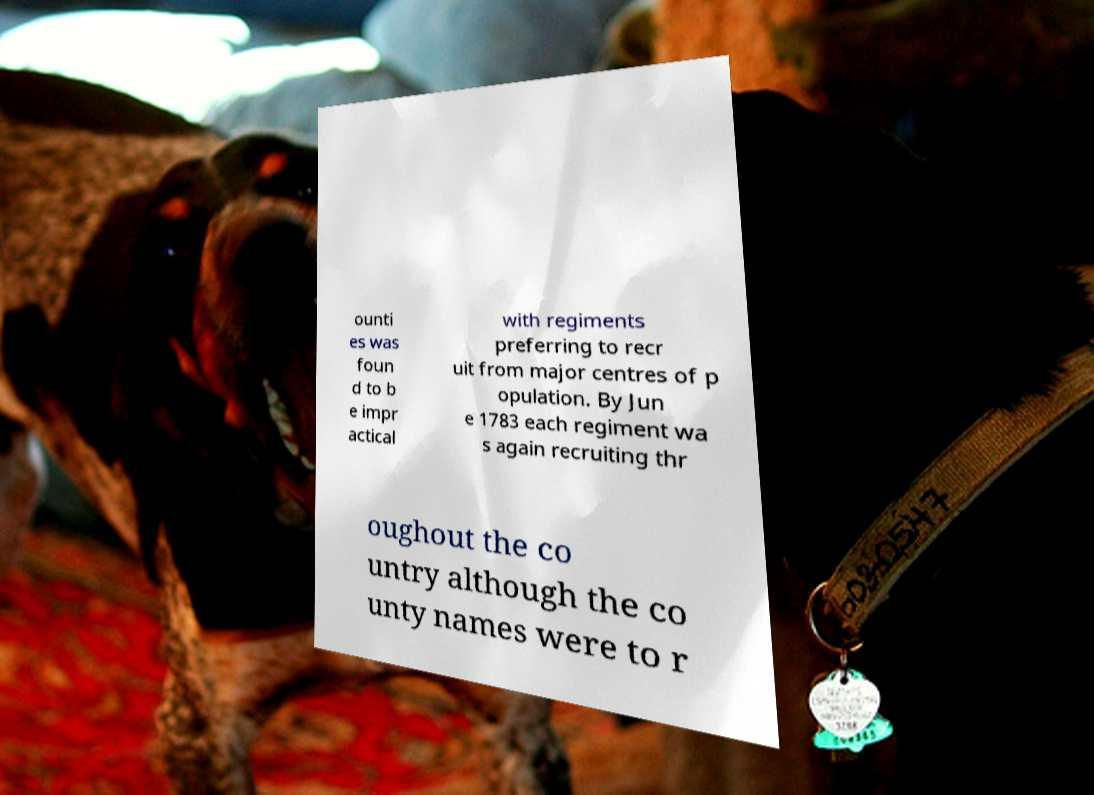Could you extract and type out the text from this image? ounti es was foun d to b e impr actical with regiments preferring to recr uit from major centres of p opulation. By Jun e 1783 each regiment wa s again recruiting thr oughout the co untry although the co unty names were to r 